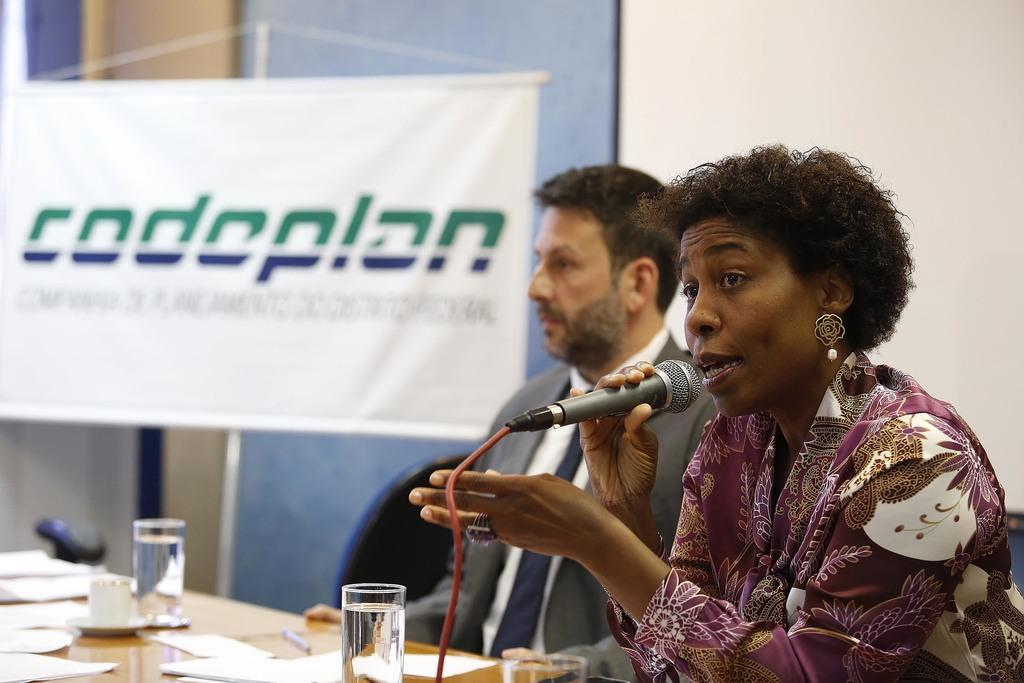How many people are in the image? There are two people in the image, a man and a woman. What are the man and woman doing in the image? The man and woman are sitting on chairs. What is the woman holding in the image? The woman is holding a mic. What is on the table in the image? There are papers, glasses, and a cup on the table. What type of soup is being served in the image? There is no soup present in the image. What organization is responsible for the event in the image? The image does not provide information about any organization or event. 